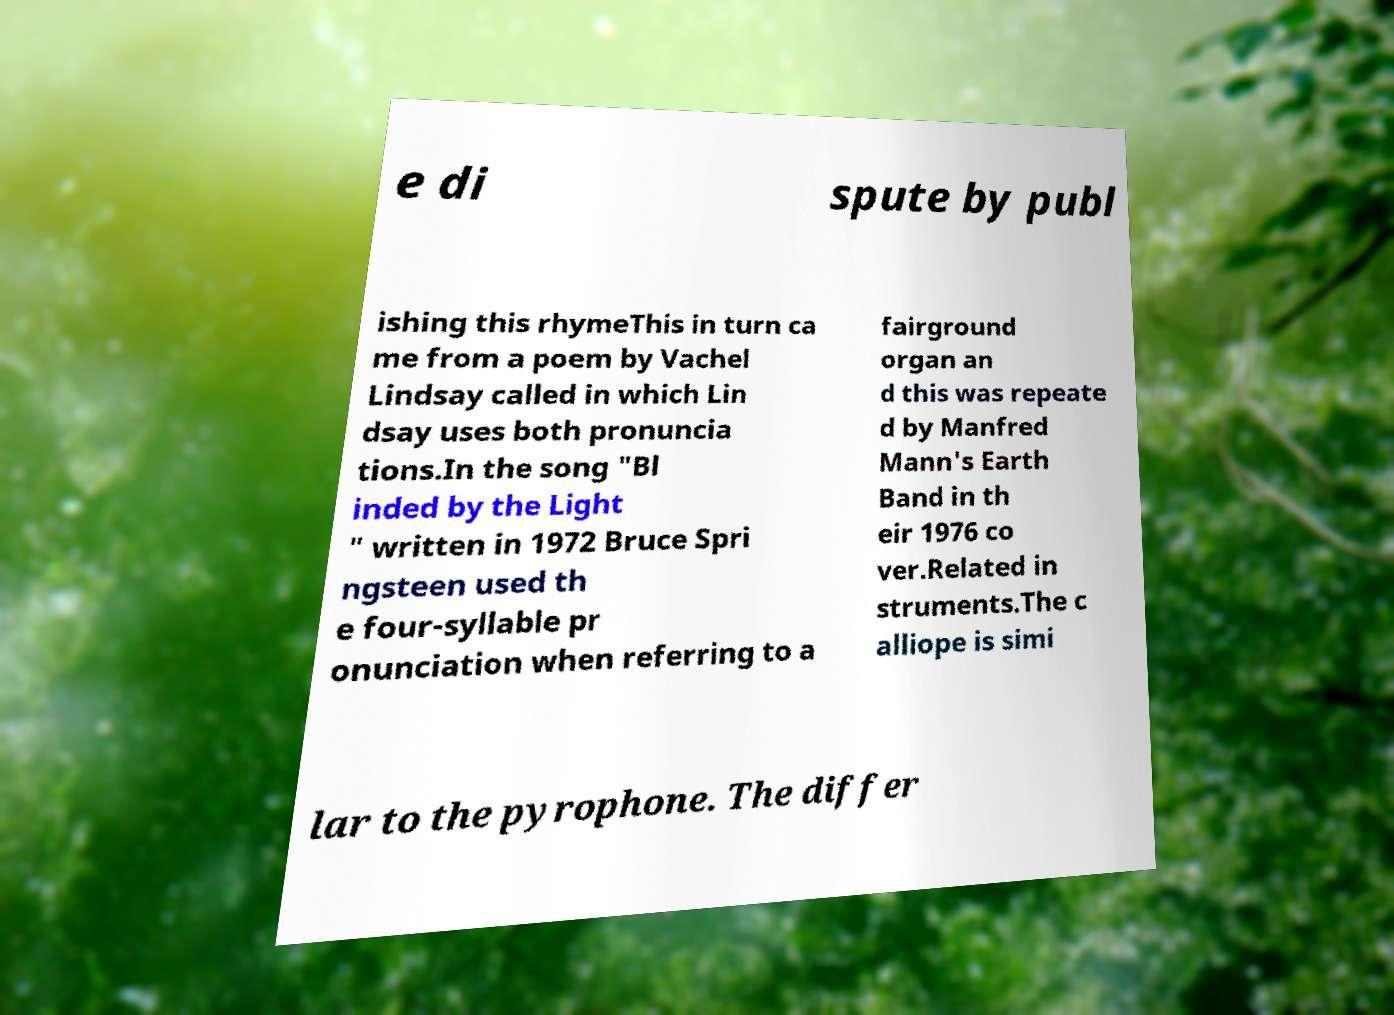I need the written content from this picture converted into text. Can you do that? e di spute by publ ishing this rhymeThis in turn ca me from a poem by Vachel Lindsay called in which Lin dsay uses both pronuncia tions.In the song "Bl inded by the Light " written in 1972 Bruce Spri ngsteen used th e four-syllable pr onunciation when referring to a fairground organ an d this was repeate d by Manfred Mann's Earth Band in th eir 1976 co ver.Related in struments.The c alliope is simi lar to the pyrophone. The differ 